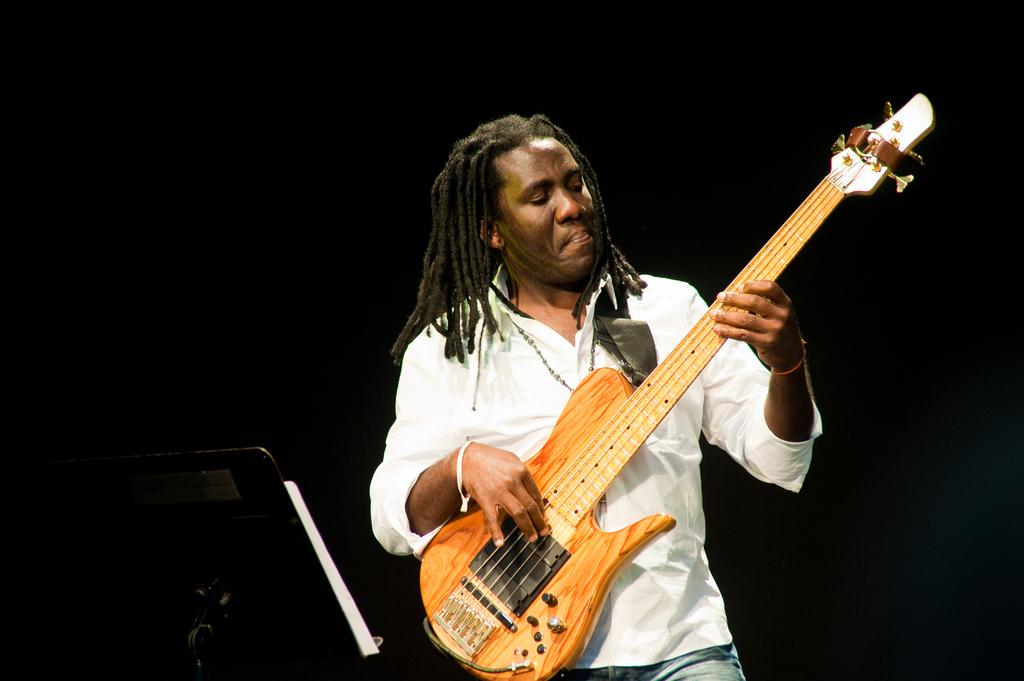What is the person in the image doing? The person is playing the guitar. What instrument is the person holding? The person is holding a guitar. What is the person wearing? The person is wearing a white shirt and jeans. What can be seen on the left side of the image? There is a stand and a book on the left side of the image. What type of yak can be seen wearing a cap in the image? There is no yak or cap present in the image. What is the governor's opinion on the person playing the guitar in the image? The image does not provide any information about the governor's opinion on the person playing the guitar. 